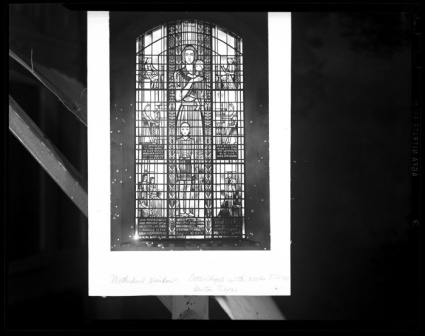Can you describe the main features of this image for me?
 The image captures a moment in a place of worship, focusing on a magnificent stained glass window. The window, rectangular with a pointed arch at the top, is a classic example of Gothic architecture. It's made up of numerous small panes of glass, meticulously arranged to form a larger picture.

The central pane is the most striking, depicting a saint or religious figure. The figure, dressed in a robe, holds a book in their hands, possibly a holy scripture. The details of the figure and the book are intricate, indicating the craftsmanship involved in creating this piece of art.

The window is set in a sturdy stone wall, a testament to the age and history of the building. The stone wall provides a stark contrast to the delicate glass artwork, adding to the overall aesthetic of the image.

Surrounding the window is scaffolding, suggesting that restoration or maintenance work is being carried out. This indicates the ongoing efforts to preserve the beauty and integrity of this historical artifact.

The photo is taken from an angle, giving the window a slightly tilted appearance. This perspective adds a dynamic element to the image, making it more visually interesting.

The image is framed by a black border, with text at the bottom. However, the text is not clear in the image. The black and white color scheme of the photo enhances the contrast, highlighting the intricate details of the stained glass window and the rough texture of the stone wall. The absence of color draws attention to the shapes, patterns, and textures in the image, creating a visually striking composition. 